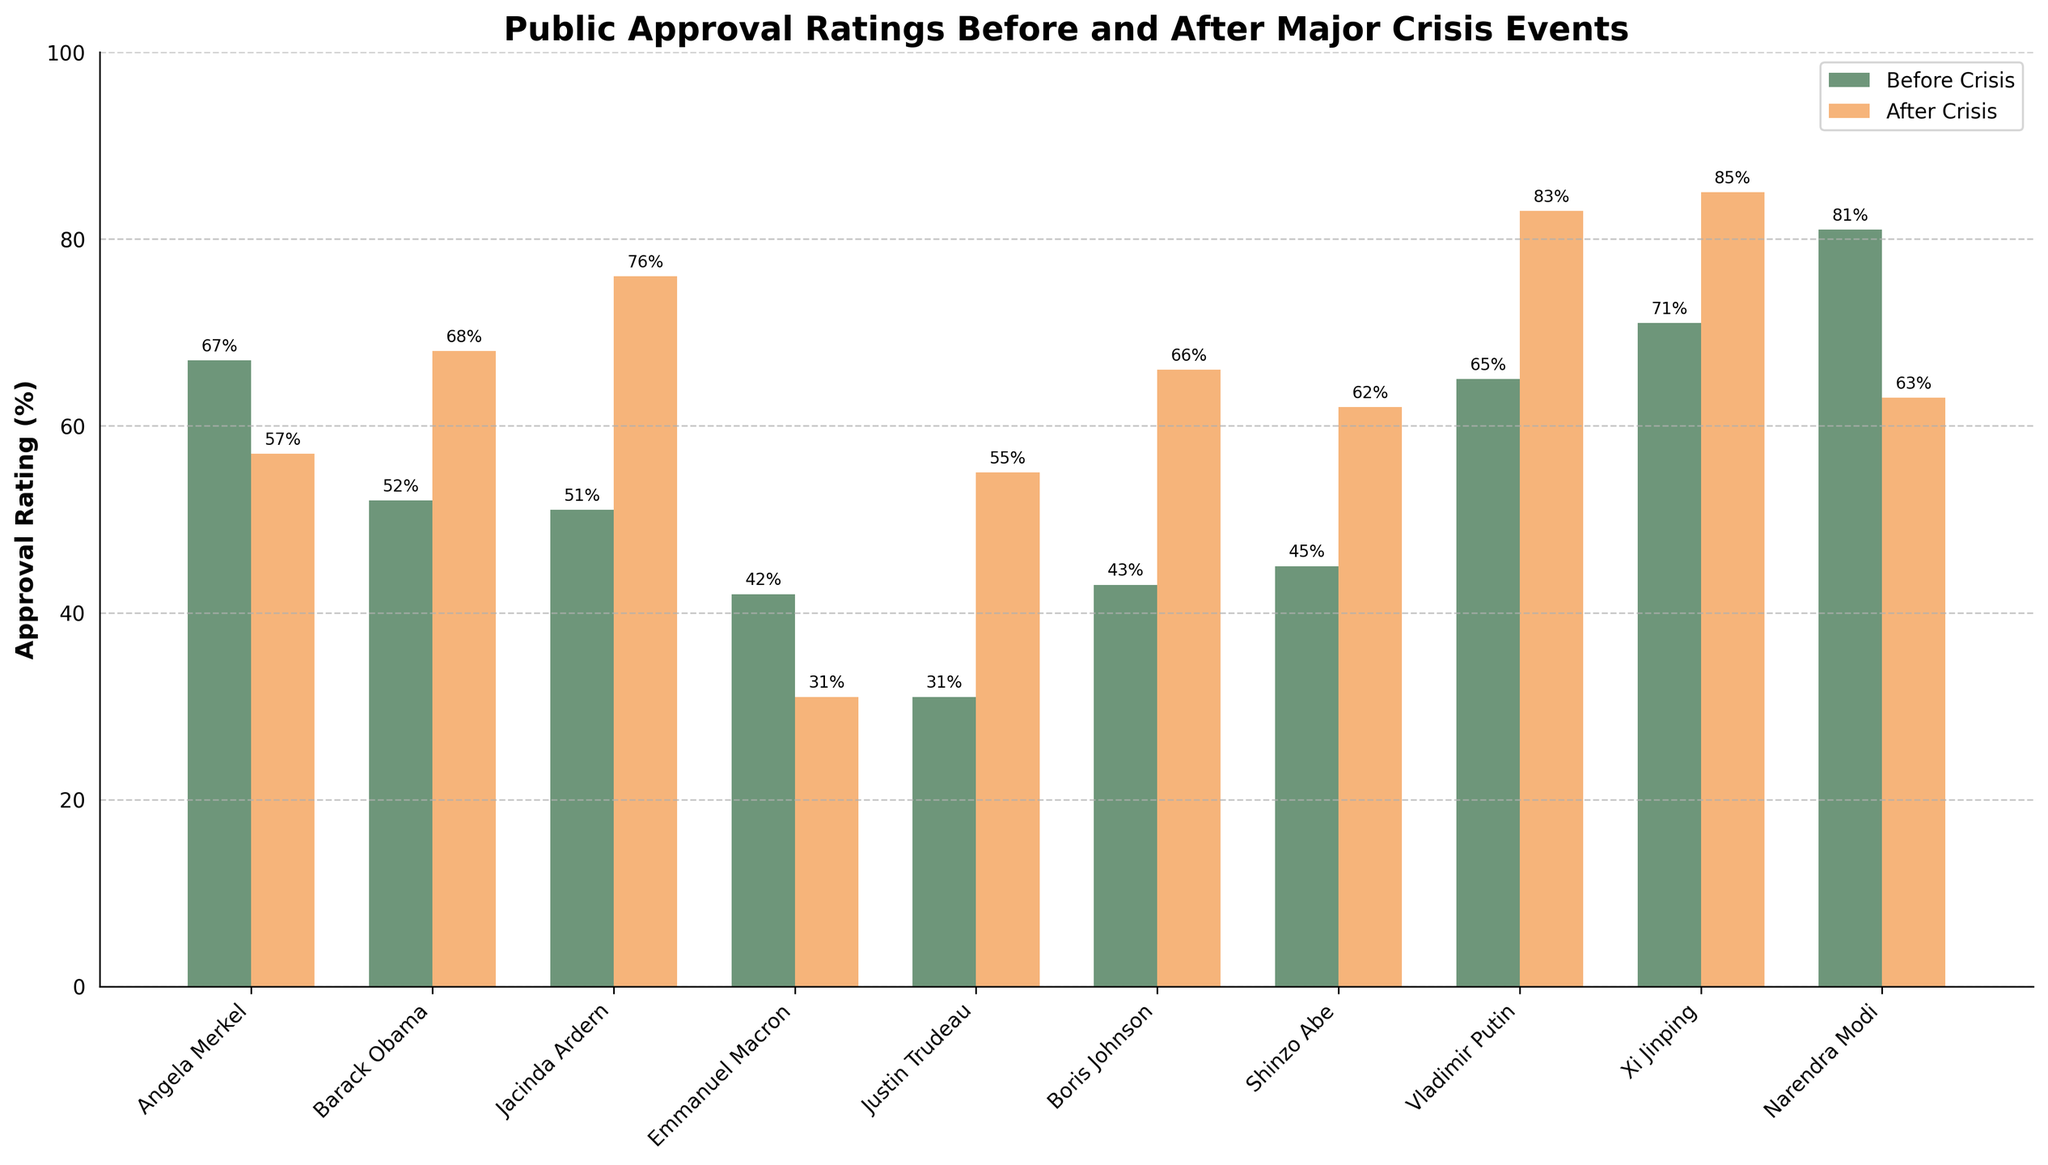Which political leader experienced the largest increase in approval ratings? To find the largest increase, we need to determine the difference between 'Approval After' and 'Approval Before' for each leader. Calculate the differences: Angela Merkel (-10), Barack Obama (+16), Jacinda Ardern (+25), Emmanuel Macron (-11), Justin Trudeau (+24), Boris Johnson (+23), Shinzo Abe (+17), Vladimir Putin (+18), Xi Jinping (+14), Narendra Modi (-18). The largest increase is for Jacinda Ardern with +25.
Answer: Jacinda Ardern Which two leaders had a decrease in approval ratings after a crisis? Observe the heights of the bars for 'Approval Before' and 'Approval After'. Leaders with 'Approval After' bars shorter than 'Approval Before' bars had a decrease. These are Angela Merkel (67 to 57) and Emmanuel Macron (42 to 31).
Answer: Angela Merkel and Emmanuel Macron Which country saw an increase in approval ratings by more than 20 percentage points after a crisis? Calculate the difference between 'Approval After' and 'Approval Before' for each leader and determine if any differences are greater than 20. Jacinda Ardern's increase was +25 and Justin Trudeau's increase was +24, both more than 20 percentage points.
Answer: New Zealand and Canada What is the average approval rating after the crisis for the leaders shown? Calculate the sum of 'Approval After' values: (57 + 68 + 76 + 31 + 55 + 66 + 62 + 83 + 85 + 63 = 646). There are 10 leaders. Divide the total by 10 (646 / 10 = 64.6).
Answer: 64.6 Which leader had the highest approval rating before the crisis? Compare the heights of the 'Approval Before' bars. Narendra Modi has the highest 'Approval Before' rating with 81 before the 2016 Demonetization in India.
Answer: Narendra Modi Between Shinzo Abe and Boris Johnson, who had a higher approval rating after the crisis? Compare the 'Approval After' ratings for Shinzo Abe (62) and Boris Johnson (66). Boris Johnson's 'Approval After' is higher.
Answer: Boris Johnson 